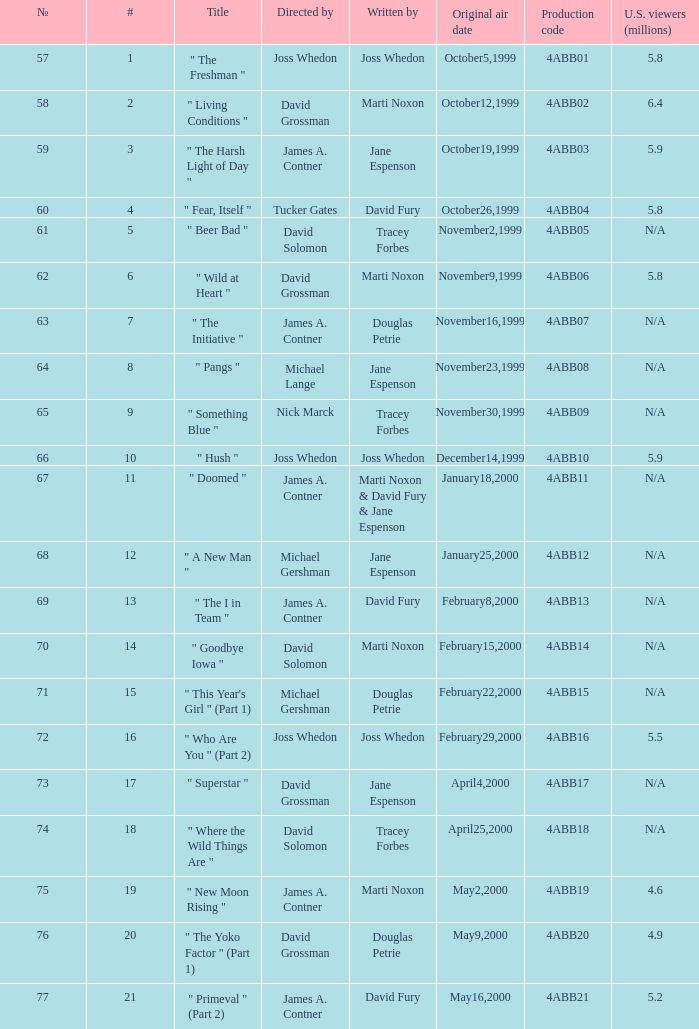What is the manufacturing code for the episode with 4ABB16. Can you parse all the data within this table? {'header': ['№', '#', 'Title', 'Directed by', 'Written by', 'Original air date', 'Production code', 'U.S. viewers (millions)'], 'rows': [['57', '1', '" The Freshman "', 'Joss Whedon', 'Joss Whedon', 'October5,1999', '4ABB01', '5.8'], ['58', '2', '" Living Conditions "', 'David Grossman', 'Marti Noxon', 'October12,1999', '4ABB02', '6.4'], ['59', '3', '" The Harsh Light of Day "', 'James A. Contner', 'Jane Espenson', 'October19,1999', '4ABB03', '5.9'], ['60', '4', '" Fear, Itself "', 'Tucker Gates', 'David Fury', 'October26,1999', '4ABB04', '5.8'], ['61', '5', '" Beer Bad "', 'David Solomon', 'Tracey Forbes', 'November2,1999', '4ABB05', 'N/A'], ['62', '6', '" Wild at Heart "', 'David Grossman', 'Marti Noxon', 'November9,1999', '4ABB06', '5.8'], ['63', '7', '" The Initiative "', 'James A. Contner', 'Douglas Petrie', 'November16,1999', '4ABB07', 'N/A'], ['64', '8', '" Pangs "', 'Michael Lange', 'Jane Espenson', 'November23,1999', '4ABB08', 'N/A'], ['65', '9', '" Something Blue "', 'Nick Marck', 'Tracey Forbes', 'November30,1999', '4ABB09', 'N/A'], ['66', '10', '" Hush "', 'Joss Whedon', 'Joss Whedon', 'December14,1999', '4ABB10', '5.9'], ['67', '11', '" Doomed "', 'James A. Contner', 'Marti Noxon & David Fury & Jane Espenson', 'January18,2000', '4ABB11', 'N/A'], ['68', '12', '" A New Man "', 'Michael Gershman', 'Jane Espenson', 'January25,2000', '4ABB12', 'N/A'], ['69', '13', '" The I in Team "', 'James A. Contner', 'David Fury', 'February8,2000', '4ABB13', 'N/A'], ['70', '14', '" Goodbye Iowa "', 'David Solomon', 'Marti Noxon', 'February15,2000', '4ABB14', 'N/A'], ['71', '15', '" This Year\'s Girl " (Part 1)', 'Michael Gershman', 'Douglas Petrie', 'February22,2000', '4ABB15', 'N/A'], ['72', '16', '" Who Are You " (Part 2)', 'Joss Whedon', 'Joss Whedon', 'February29,2000', '4ABB16', '5.5'], ['73', '17', '" Superstar "', 'David Grossman', 'Jane Espenson', 'April4,2000', '4ABB17', 'N/A'], ['74', '18', '" Where the Wild Things Are "', 'David Solomon', 'Tracey Forbes', 'April25,2000', '4ABB18', 'N/A'], ['75', '19', '" New Moon Rising "', 'James A. Contner', 'Marti Noxon', 'May2,2000', '4ABB19', '4.6'], ['76', '20', '" The Yoko Factor " (Part 1)', 'David Grossman', 'Douglas Petrie', 'May9,2000', '4ABB20', '4.9'], ['77', '21', '" Primeval " (Part 2)', 'James A. Contner', 'David Fury', 'May16,2000', '4ABB21', '5.2']]} 